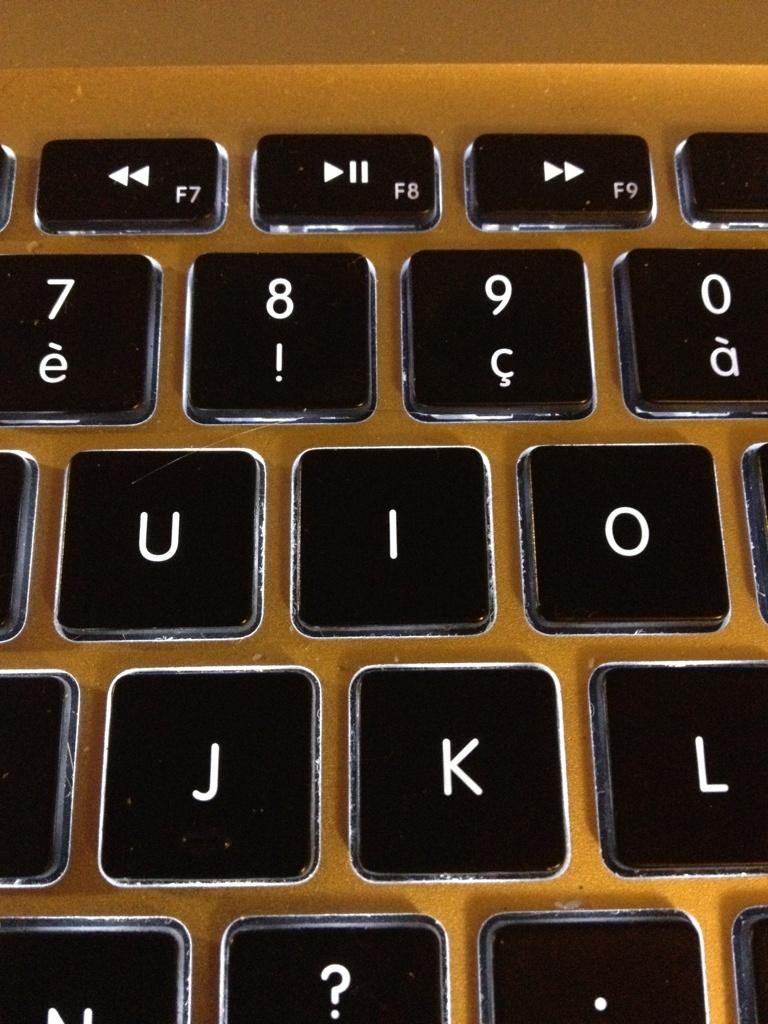<image>
Offer a succinct explanation of the picture presented. a key board with the keys j,k,l,u,i and o 